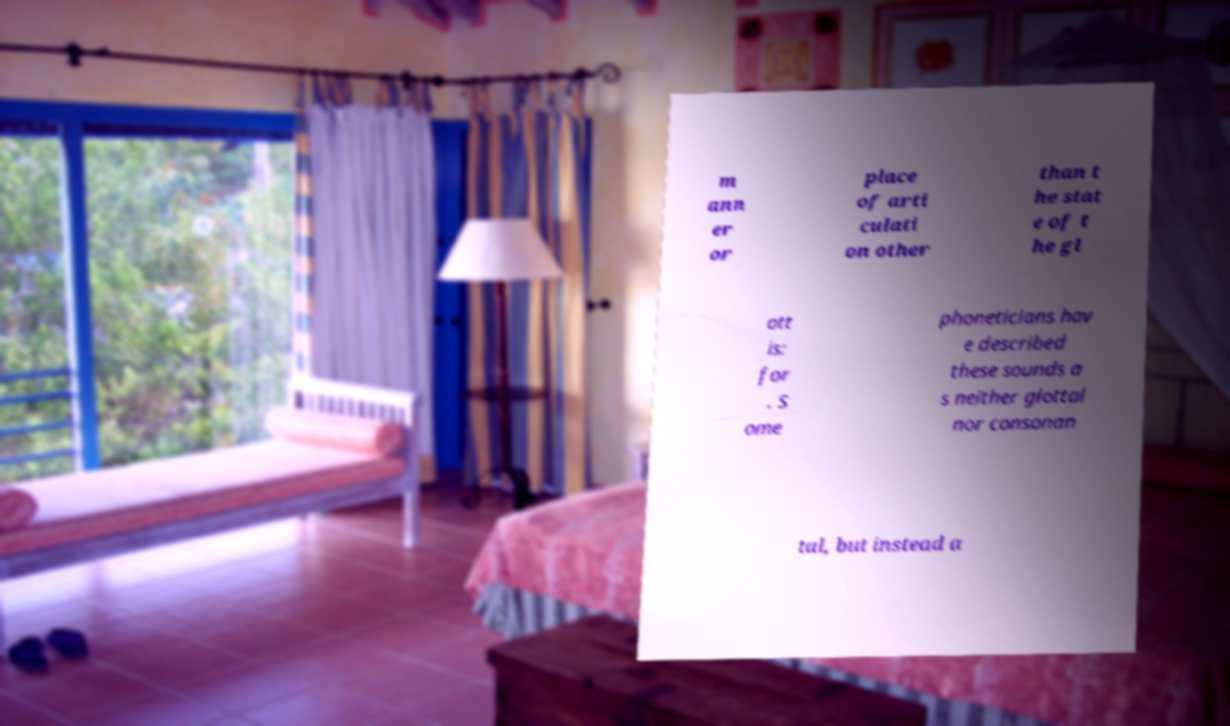Please identify and transcribe the text found in this image. m ann er or place of arti culati on other than t he stat e of t he gl ott is: for . S ome phoneticians hav e described these sounds a s neither glottal nor consonan tal, but instead a 